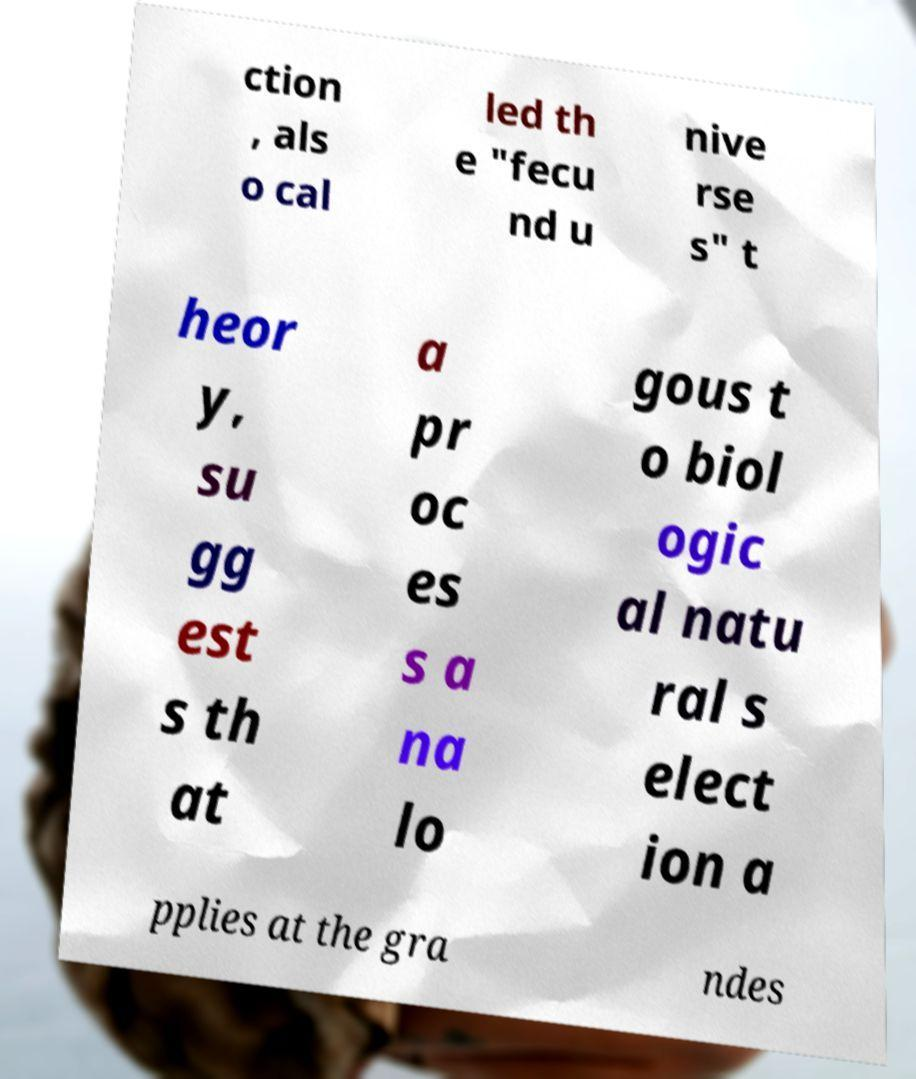Could you assist in decoding the text presented in this image and type it out clearly? ction , als o cal led th e "fecu nd u nive rse s" t heor y, su gg est s th at a pr oc es s a na lo gous t o biol ogic al natu ral s elect ion a pplies at the gra ndes 